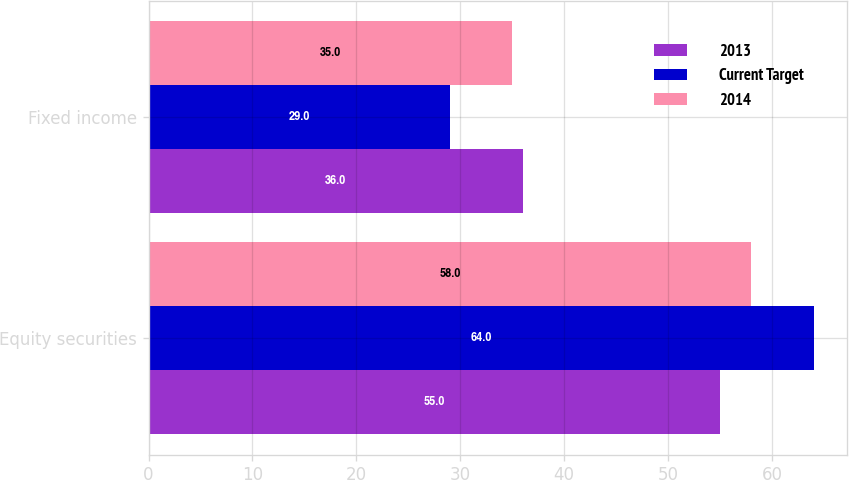Convert chart to OTSL. <chart><loc_0><loc_0><loc_500><loc_500><stacked_bar_chart><ecel><fcel>Equity securities<fcel>Fixed income<nl><fcel>2013<fcel>55<fcel>36<nl><fcel>Current Target<fcel>64<fcel>29<nl><fcel>2014<fcel>58<fcel>35<nl></chart> 